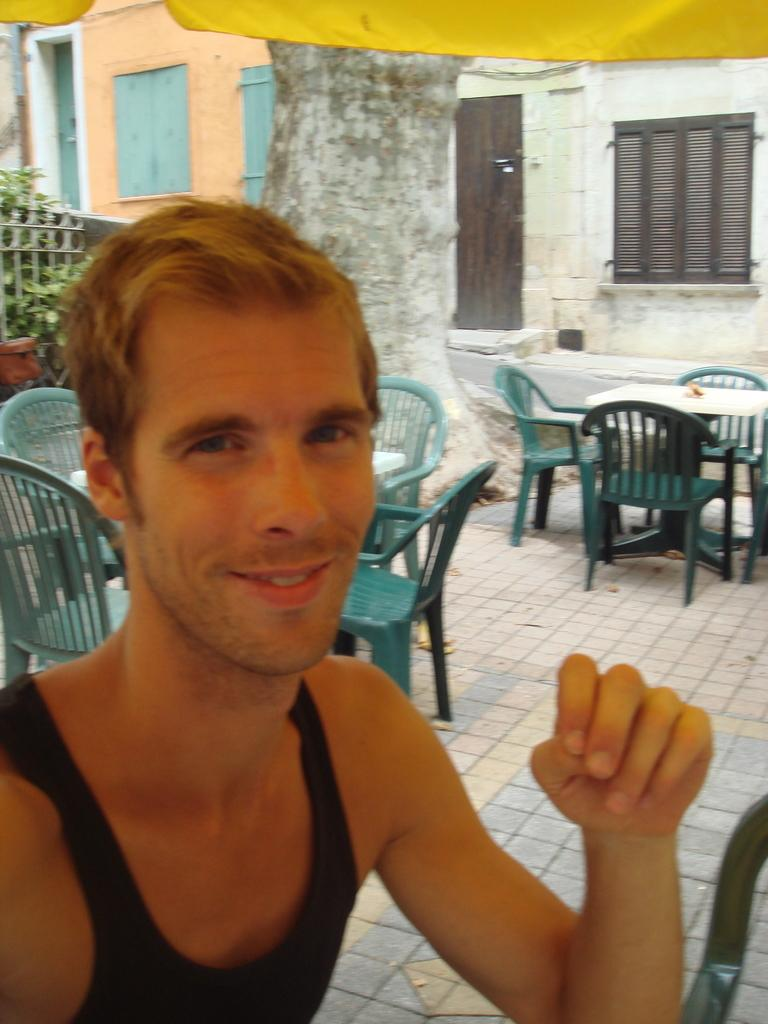What is the man in the image doing? The man is sitting on a chair in the image. What else can be seen on the ground in the image? There are chairs and tables on the ground in the image. What is visible in the background of the image? There is a building visible in the background of the image. What type of vegetation is present on the ground in the image? There are plants on the ground in the image. How many boats are visible in the image? There are no boats present in the image. What theory does the man in the image support? The image does not provide any information about the man's theories or beliefs. 